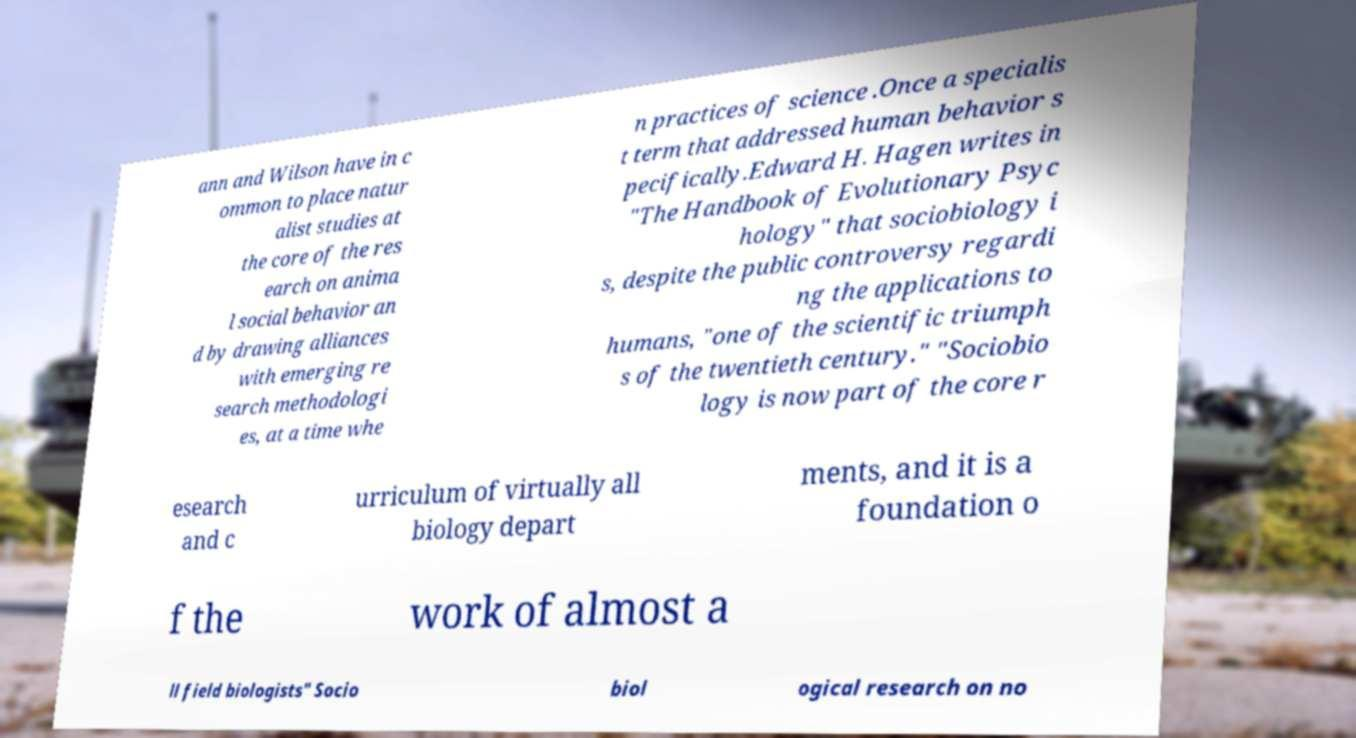For documentation purposes, I need the text within this image transcribed. Could you provide that? ann and Wilson have in c ommon to place natur alist studies at the core of the res earch on anima l social behavior an d by drawing alliances with emerging re search methodologi es, at a time whe n practices of science .Once a specialis t term that addressed human behavior s pecifically.Edward H. Hagen writes in "The Handbook of Evolutionary Psyc hology" that sociobiology i s, despite the public controversy regardi ng the applications to humans, "one of the scientific triumph s of the twentieth century." "Sociobio logy is now part of the core r esearch and c urriculum of virtually all biology depart ments, and it is a foundation o f the work of almost a ll field biologists" Socio biol ogical research on no 